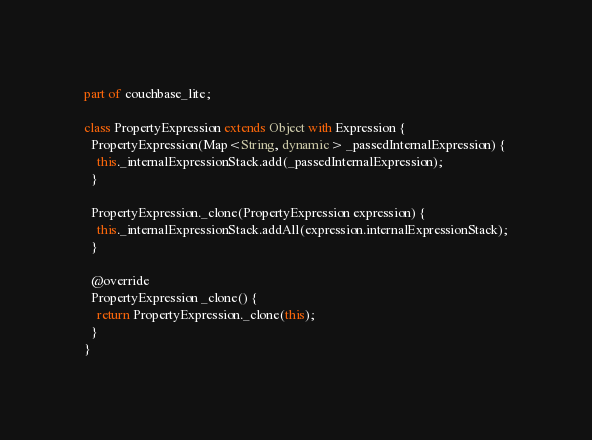<code> <loc_0><loc_0><loc_500><loc_500><_Dart_>part of couchbase_lite;

class PropertyExpression extends Object with Expression {
  PropertyExpression(Map<String, dynamic> _passedInternalExpression) {
    this._internalExpressionStack.add(_passedInternalExpression);
  }

  PropertyExpression._clone(PropertyExpression expression) {
    this._internalExpressionStack.addAll(expression.internalExpressionStack);
  }

  @override
  PropertyExpression _clone() {
    return PropertyExpression._clone(this);
  }
}
</code> 